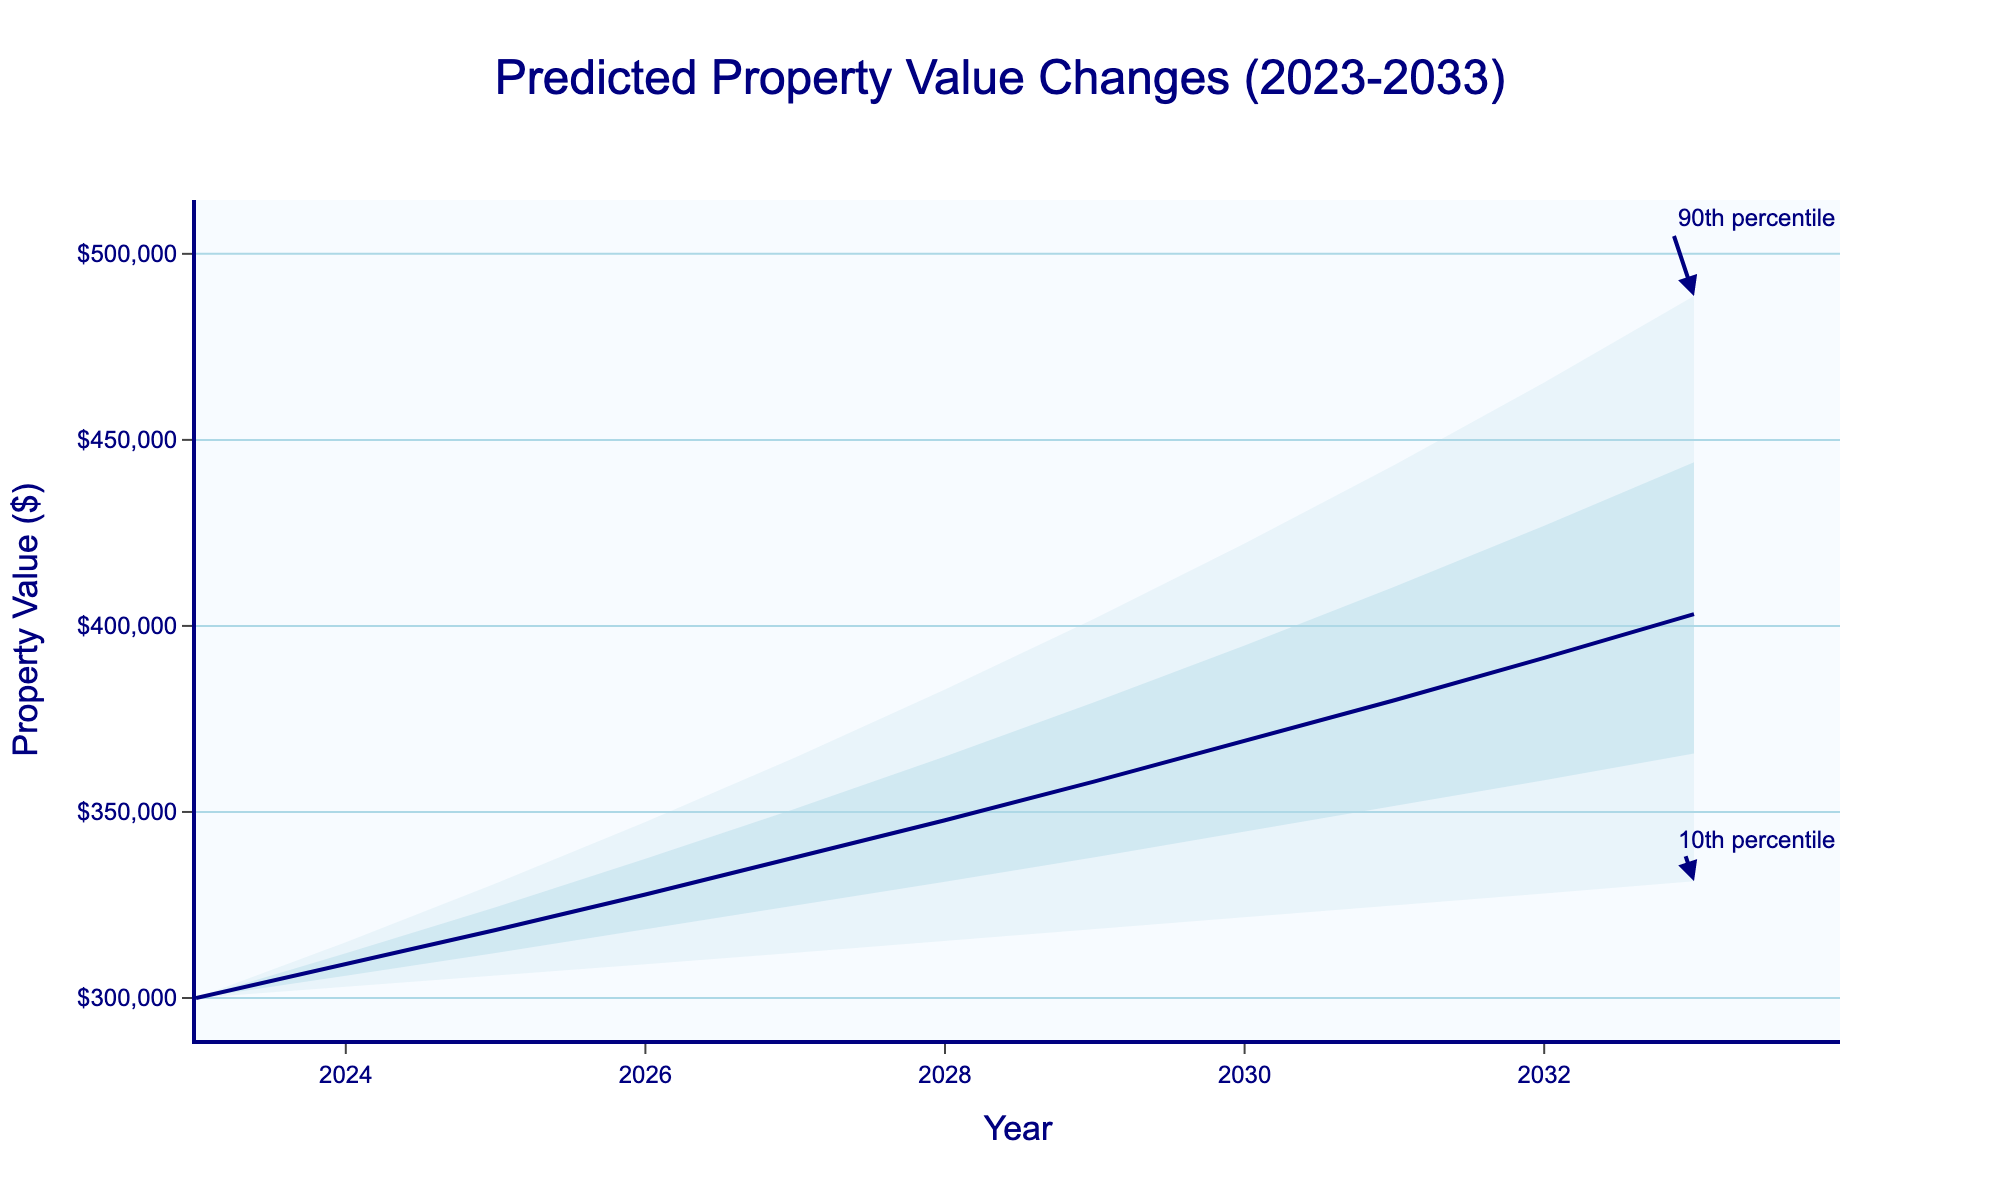What's the title of the chart? The title is usually located at the top of the chart. In this case, it reads "Predicted Property Value Changes (2023-2033)", clearly summarizing the chart's content.
Answer: Predicted Property Value Changes (2023-2033) How does the median property value change from 2023 to 2033? To find how the median value changes, look at the median values for 2023 and 2033. The median in 2023 is $300,000, and in 2033 it is $403,175. Calculate the difference: $403,175 - $300,000 = $103,175.
Answer: $103,175 Which year has the highest median property value? The year with the highest median property value can be determined by comparing the median values for each year. Here, 2033 has the highest median value of $403,175.
Answer: 2033 What is the range of property values in 2027 considering the 10th and 90th percentiles? Look at the 10th and 90th percentile values for 2027. The lower 10th percentile is $312,181 and the upper 90th percentile is $364,652. The range is calculated as $364,652 - $312,181.
Answer: $52,471 How do the 75th and 25th percentile values change from 2024 to 2028? Find the 75th and 25th percentile values for 2024 and 2028 and calculate the difference: 2024 (75th: $312,000, 25th: $306,000), 2028 (75th: $364,929, 25th: $331,224). 75th percentile change: $364,929 - $312,000. 25th percentile change: $331,224 - $306,000.
Answer: $52,929 (75th), $25,224 (25th) In which year do the property values show the widest uncertainty range according to the 10th and 90th percentiles? Calculate the uncertainty range for each year (Upper_90 - Lower_10) and identify the maximum. For 2033: $488,669 - $331,386 = $157,283, which is the widest.
Answer: 2033 What is the trend of median property values over the decade? Observing the median line from 2023 to 2033 shows a consistent upward trend in property values, indicating overall property value appreciation over the decade.
Answer: Upward trend By how much is the median property value expected to increase between the first and last year? Find the median values for the first and last year (2023: $300,000, 2033: $403,175). Calculate the increase: $403,175 - $300,000 = $103,175.
Answer: $103,175 Is there any year when the 10th percentile value decreases from the previous year? Check the 10th percentile values for each year. They consistently increase year-over-year, with no decreases observed.
Answer: No What percentage of projected property values fall below the median in 2032? By definition, the median divides the data into two equal parts. Therefore, 50% of the values fall below the median.
Answer: 50% 